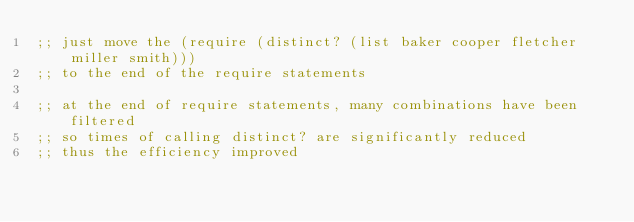Convert code to text. <code><loc_0><loc_0><loc_500><loc_500><_Scheme_>;; just move the (require (distinct? (list baker cooper fletcher miller smith)))
;; to the end of the require statements

;; at the end of require statements, many combinations have been filtered
;; so times of calling distinct? are significantly reduced
;; thus the efficiency improved
</code> 